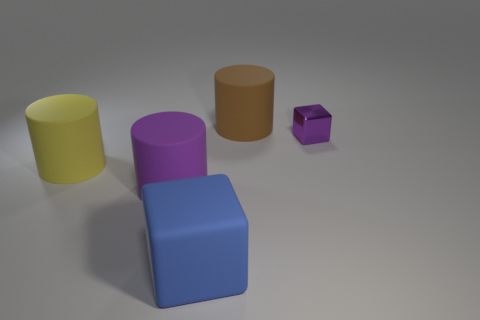Is there any other thing that is the same size as the purple cube?
Offer a terse response. No. How big is the rubber cylinder in front of the big yellow object?
Offer a terse response. Large. What number of brown matte cylinders are the same size as the rubber cube?
Ensure brevity in your answer.  1. There is a object that is on the left side of the small cube and to the right of the big blue rubber object; what is its material?
Your answer should be very brief. Rubber. There is a purple cylinder that is the same size as the brown rubber object; what material is it?
Give a very brief answer. Rubber. There is a purple object to the left of the brown rubber object on the left side of the thing to the right of the large brown matte object; what is its size?
Provide a short and direct response. Large. There is a brown cylinder that is the same material as the big blue thing; what size is it?
Provide a short and direct response. Large. There is a blue block; is it the same size as the object right of the large brown object?
Keep it short and to the point. No. There is a big matte thing right of the blue matte cube; what shape is it?
Give a very brief answer. Cylinder. There is a purple thing right of the matte thing that is to the right of the blue matte object; are there any large purple cylinders that are behind it?
Provide a succinct answer. No. 